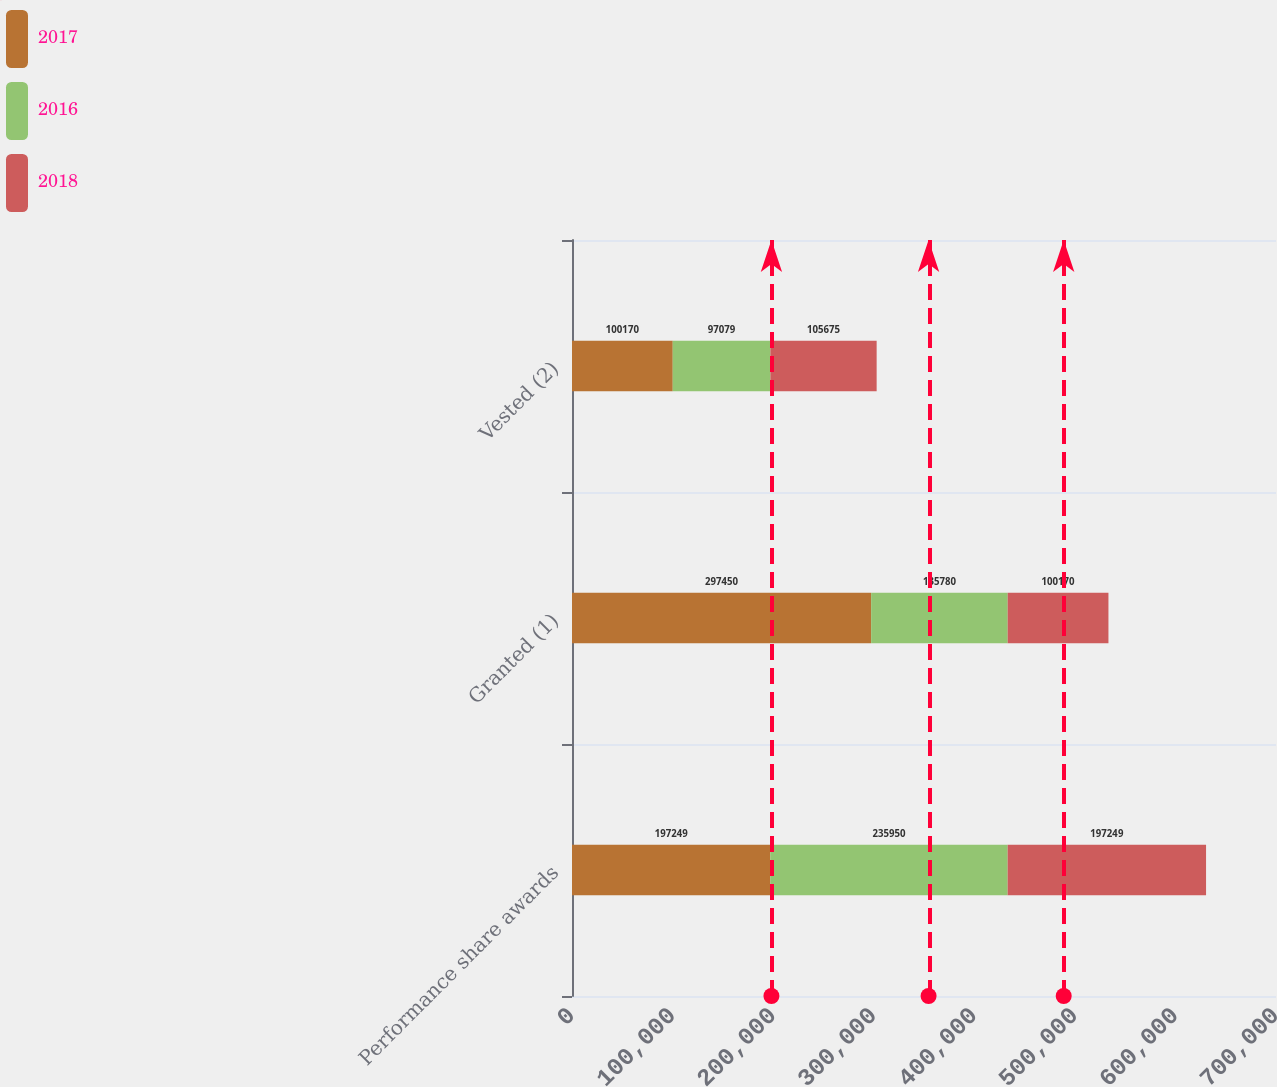<chart> <loc_0><loc_0><loc_500><loc_500><stacked_bar_chart><ecel><fcel>Performance share awards<fcel>Granted (1)<fcel>Vested (2)<nl><fcel>2017<fcel>197249<fcel>297450<fcel>100170<nl><fcel>2016<fcel>235950<fcel>135780<fcel>97079<nl><fcel>2018<fcel>197249<fcel>100170<fcel>105675<nl></chart> 